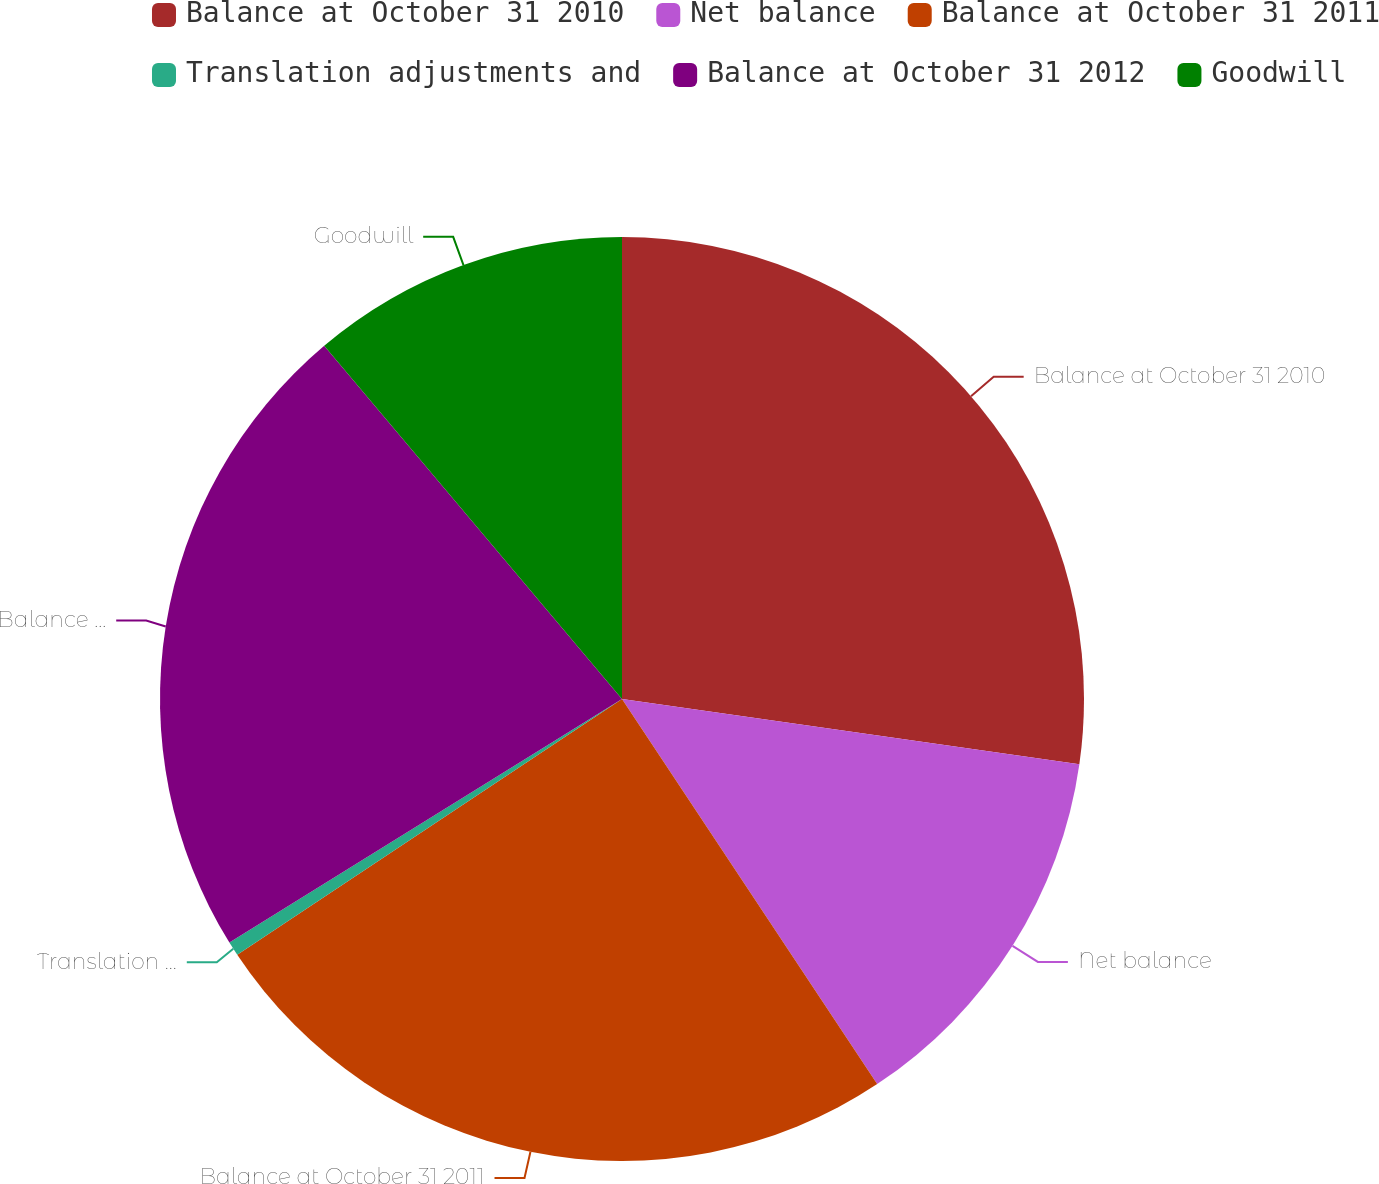Convert chart. <chart><loc_0><loc_0><loc_500><loc_500><pie_chart><fcel>Balance at October 31 2010<fcel>Net balance<fcel>Balance at October 31 2011<fcel>Translation adjustments and<fcel>Balance at October 31 2012<fcel>Goodwill<nl><fcel>27.26%<fcel>13.43%<fcel>24.98%<fcel>0.5%<fcel>22.69%<fcel>11.15%<nl></chart> 